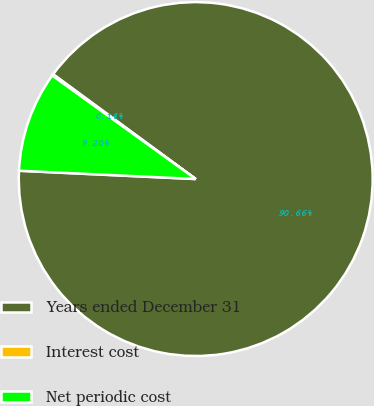Convert chart to OTSL. <chart><loc_0><loc_0><loc_500><loc_500><pie_chart><fcel>Years ended December 31<fcel>Interest cost<fcel>Net periodic cost<nl><fcel>90.66%<fcel>0.14%<fcel>9.2%<nl></chart> 